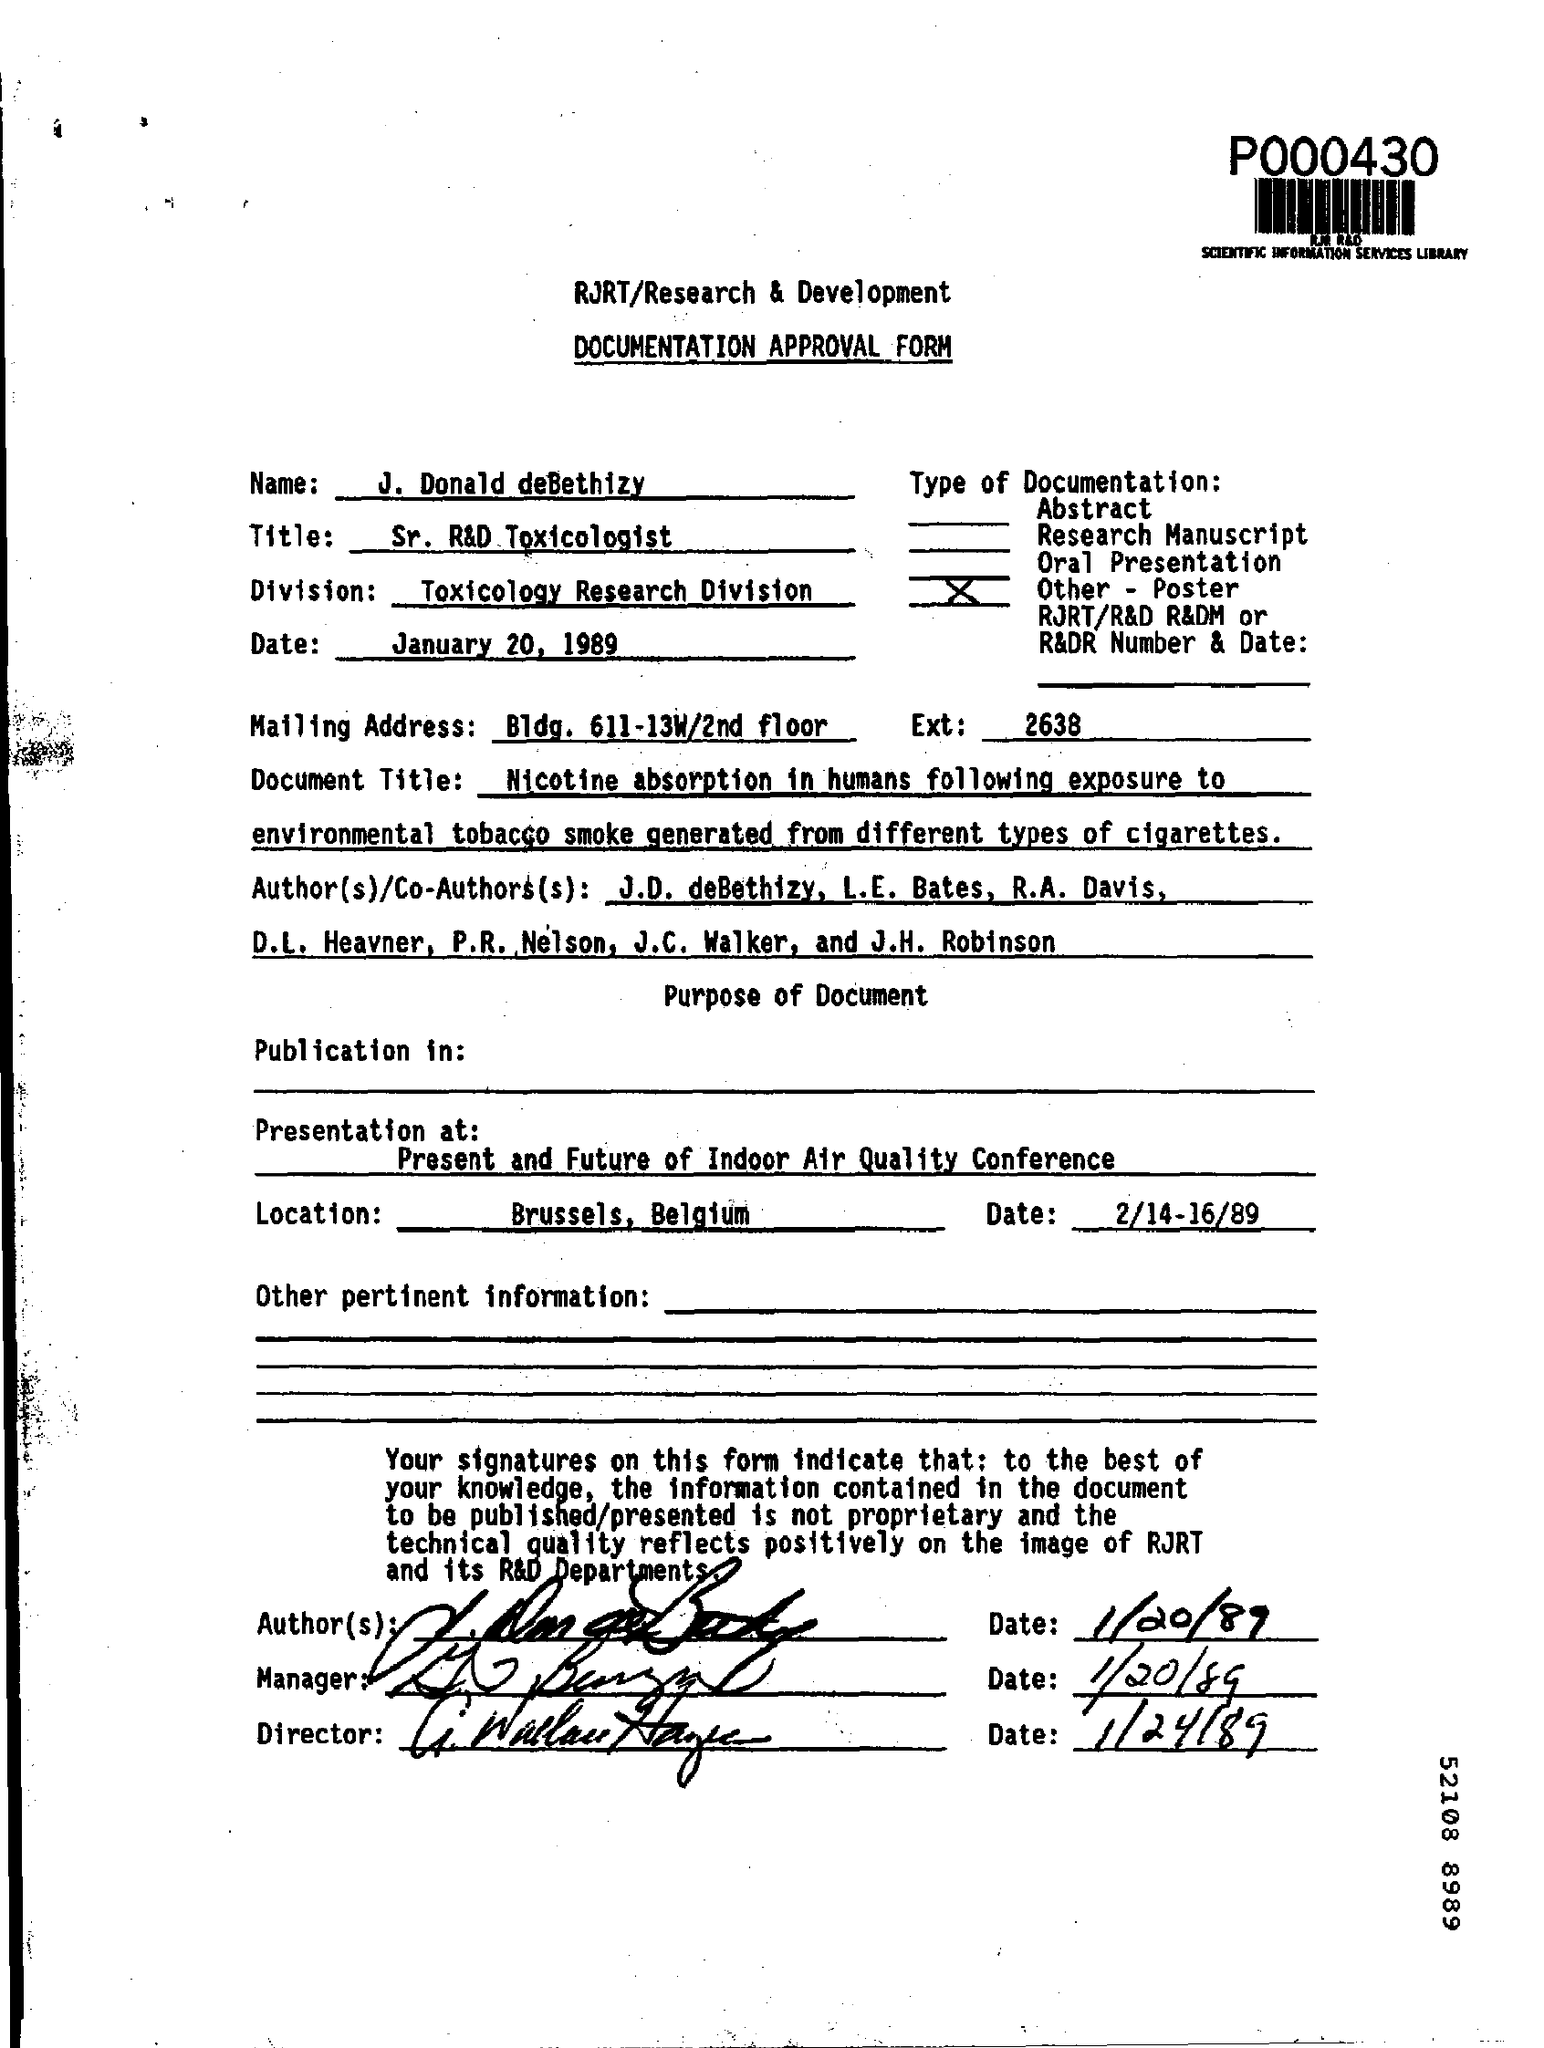What type of form is given here?
Provide a short and direct response. Documentation approval form. What is the name mentioned in the document?
Offer a very short reply. J. Donald deBethizy. What is the job title of J. Donald deBethizy?
Keep it short and to the point. Sr. R&D toxicologist. In which division, J. Donald deBethizy works?
Ensure brevity in your answer.  Toxicology Research Division. What is the mailing address given in the document?
Ensure brevity in your answer.  Bldg. 611-13W/2nd floor. Where is the Presentation held?
Ensure brevity in your answer.  Present and Future of Indoor Air Quality Conference. In which location, the conference is held?
Ensure brevity in your answer.  Brussels, Belgium. On which date, the conference is scheduled?
Your answer should be compact. 2/14-16/89. 